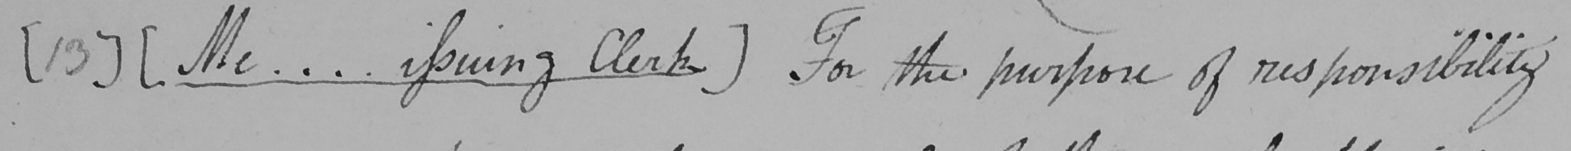Transcribe the text shown in this historical manuscript line. [ 13 ]  [ Me ... . issuing Clerk ]  For the purpose of responsibility 